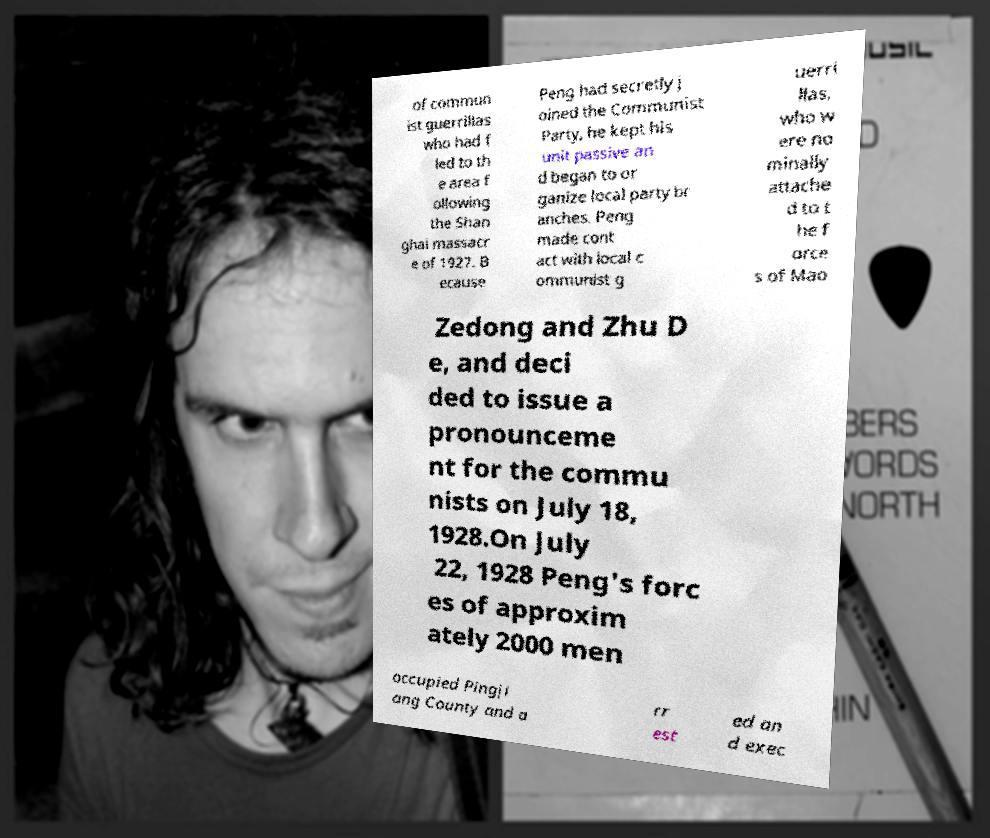Can you read and provide the text displayed in the image?This photo seems to have some interesting text. Can you extract and type it out for me? of commun ist guerrillas who had f led to th e area f ollowing the Shan ghai massacr e of 1927. B ecause Peng had secretly j oined the Communist Party, he kept his unit passive an d began to or ganize local party br anches. Peng made cont act with local c ommunist g uerri llas, who w ere no minally attache d to t he f orce s of Mao Zedong and Zhu D e, and deci ded to issue a pronounceme nt for the commu nists on July 18, 1928.On July 22, 1928 Peng's forc es of approxim ately 2000 men occupied Pingji ang County and a rr est ed an d exec 